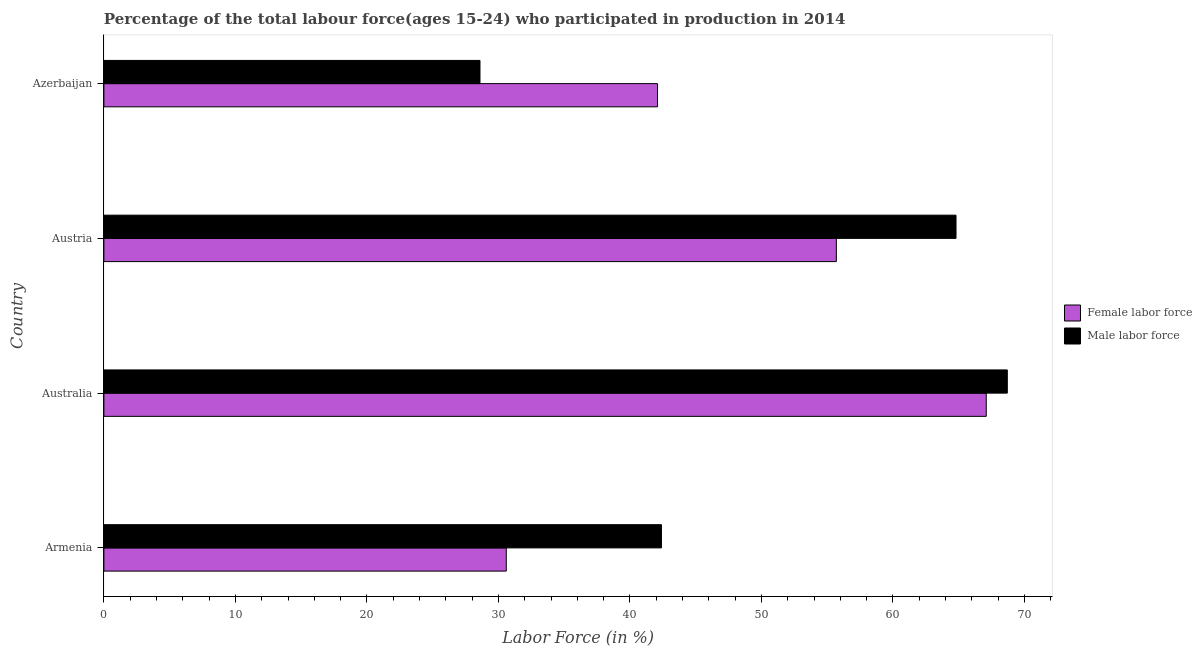How many different coloured bars are there?
Provide a succinct answer. 2. Are the number of bars per tick equal to the number of legend labels?
Ensure brevity in your answer.  Yes. Are the number of bars on each tick of the Y-axis equal?
Provide a short and direct response. Yes. What is the label of the 1st group of bars from the top?
Make the answer very short. Azerbaijan. In how many cases, is the number of bars for a given country not equal to the number of legend labels?
Offer a very short reply. 0. What is the percentage of female labor force in Armenia?
Offer a terse response. 30.6. Across all countries, what is the maximum percentage of female labor force?
Offer a terse response. 67.1. Across all countries, what is the minimum percentage of male labour force?
Keep it short and to the point. 28.6. In which country was the percentage of male labour force minimum?
Give a very brief answer. Azerbaijan. What is the total percentage of male labour force in the graph?
Provide a succinct answer. 204.5. What is the difference between the percentage of female labor force in Australia and that in Austria?
Your response must be concise. 11.4. What is the difference between the percentage of male labour force in Austria and the percentage of female labor force in Armenia?
Ensure brevity in your answer.  34.2. What is the average percentage of female labor force per country?
Your answer should be compact. 48.88. What is the difference between the percentage of male labour force and percentage of female labor force in Armenia?
Your answer should be very brief. 11.8. In how many countries, is the percentage of male labour force greater than 24 %?
Give a very brief answer. 4. What is the ratio of the percentage of male labour force in Armenia to that in Australia?
Your response must be concise. 0.62. Is the percentage of female labor force in Australia less than that in Austria?
Make the answer very short. No. Is the difference between the percentage of male labour force in Australia and Azerbaijan greater than the difference between the percentage of female labor force in Australia and Azerbaijan?
Offer a very short reply. Yes. What is the difference between the highest and the second highest percentage of female labor force?
Your response must be concise. 11.4. What is the difference between the highest and the lowest percentage of male labour force?
Give a very brief answer. 40.1. Is the sum of the percentage of female labor force in Australia and Azerbaijan greater than the maximum percentage of male labour force across all countries?
Keep it short and to the point. Yes. What does the 1st bar from the top in Azerbaijan represents?
Ensure brevity in your answer.  Male labor force. What does the 2nd bar from the bottom in Austria represents?
Your answer should be compact. Male labor force. What is the difference between two consecutive major ticks on the X-axis?
Offer a terse response. 10. What is the title of the graph?
Offer a terse response. Percentage of the total labour force(ages 15-24) who participated in production in 2014. What is the label or title of the X-axis?
Ensure brevity in your answer.  Labor Force (in %). What is the Labor Force (in %) of Female labor force in Armenia?
Your response must be concise. 30.6. What is the Labor Force (in %) of Male labor force in Armenia?
Provide a short and direct response. 42.4. What is the Labor Force (in %) of Female labor force in Australia?
Provide a short and direct response. 67.1. What is the Labor Force (in %) in Male labor force in Australia?
Give a very brief answer. 68.7. What is the Labor Force (in %) in Female labor force in Austria?
Offer a terse response. 55.7. What is the Labor Force (in %) of Male labor force in Austria?
Provide a succinct answer. 64.8. What is the Labor Force (in %) of Female labor force in Azerbaijan?
Offer a terse response. 42.1. What is the Labor Force (in %) of Male labor force in Azerbaijan?
Make the answer very short. 28.6. Across all countries, what is the maximum Labor Force (in %) in Female labor force?
Offer a very short reply. 67.1. Across all countries, what is the maximum Labor Force (in %) of Male labor force?
Your response must be concise. 68.7. Across all countries, what is the minimum Labor Force (in %) in Female labor force?
Provide a short and direct response. 30.6. Across all countries, what is the minimum Labor Force (in %) in Male labor force?
Your answer should be compact. 28.6. What is the total Labor Force (in %) in Female labor force in the graph?
Give a very brief answer. 195.5. What is the total Labor Force (in %) of Male labor force in the graph?
Your answer should be very brief. 204.5. What is the difference between the Labor Force (in %) in Female labor force in Armenia and that in Australia?
Ensure brevity in your answer.  -36.5. What is the difference between the Labor Force (in %) of Male labor force in Armenia and that in Australia?
Make the answer very short. -26.3. What is the difference between the Labor Force (in %) of Female labor force in Armenia and that in Austria?
Keep it short and to the point. -25.1. What is the difference between the Labor Force (in %) of Male labor force in Armenia and that in Austria?
Your answer should be very brief. -22.4. What is the difference between the Labor Force (in %) of Male labor force in Armenia and that in Azerbaijan?
Provide a short and direct response. 13.8. What is the difference between the Labor Force (in %) of Female labor force in Australia and that in Austria?
Your response must be concise. 11.4. What is the difference between the Labor Force (in %) in Male labor force in Australia and that in Austria?
Offer a terse response. 3.9. What is the difference between the Labor Force (in %) in Male labor force in Australia and that in Azerbaijan?
Keep it short and to the point. 40.1. What is the difference between the Labor Force (in %) of Female labor force in Austria and that in Azerbaijan?
Make the answer very short. 13.6. What is the difference between the Labor Force (in %) of Male labor force in Austria and that in Azerbaijan?
Your answer should be very brief. 36.2. What is the difference between the Labor Force (in %) in Female labor force in Armenia and the Labor Force (in %) in Male labor force in Australia?
Offer a very short reply. -38.1. What is the difference between the Labor Force (in %) of Female labor force in Armenia and the Labor Force (in %) of Male labor force in Austria?
Give a very brief answer. -34.2. What is the difference between the Labor Force (in %) of Female labor force in Armenia and the Labor Force (in %) of Male labor force in Azerbaijan?
Your answer should be very brief. 2. What is the difference between the Labor Force (in %) of Female labor force in Australia and the Labor Force (in %) of Male labor force in Austria?
Provide a short and direct response. 2.3. What is the difference between the Labor Force (in %) in Female labor force in Australia and the Labor Force (in %) in Male labor force in Azerbaijan?
Offer a terse response. 38.5. What is the difference between the Labor Force (in %) in Female labor force in Austria and the Labor Force (in %) in Male labor force in Azerbaijan?
Keep it short and to the point. 27.1. What is the average Labor Force (in %) of Female labor force per country?
Ensure brevity in your answer.  48.88. What is the average Labor Force (in %) of Male labor force per country?
Keep it short and to the point. 51.12. What is the difference between the Labor Force (in %) in Female labor force and Labor Force (in %) in Male labor force in Australia?
Provide a succinct answer. -1.6. What is the ratio of the Labor Force (in %) of Female labor force in Armenia to that in Australia?
Your answer should be compact. 0.46. What is the ratio of the Labor Force (in %) of Male labor force in Armenia to that in Australia?
Offer a very short reply. 0.62. What is the ratio of the Labor Force (in %) of Female labor force in Armenia to that in Austria?
Give a very brief answer. 0.55. What is the ratio of the Labor Force (in %) of Male labor force in Armenia to that in Austria?
Ensure brevity in your answer.  0.65. What is the ratio of the Labor Force (in %) in Female labor force in Armenia to that in Azerbaijan?
Your response must be concise. 0.73. What is the ratio of the Labor Force (in %) in Male labor force in Armenia to that in Azerbaijan?
Keep it short and to the point. 1.48. What is the ratio of the Labor Force (in %) of Female labor force in Australia to that in Austria?
Provide a short and direct response. 1.2. What is the ratio of the Labor Force (in %) in Male labor force in Australia to that in Austria?
Make the answer very short. 1.06. What is the ratio of the Labor Force (in %) in Female labor force in Australia to that in Azerbaijan?
Provide a short and direct response. 1.59. What is the ratio of the Labor Force (in %) of Male labor force in Australia to that in Azerbaijan?
Make the answer very short. 2.4. What is the ratio of the Labor Force (in %) in Female labor force in Austria to that in Azerbaijan?
Ensure brevity in your answer.  1.32. What is the ratio of the Labor Force (in %) in Male labor force in Austria to that in Azerbaijan?
Offer a very short reply. 2.27. What is the difference between the highest and the second highest Labor Force (in %) of Male labor force?
Provide a short and direct response. 3.9. What is the difference between the highest and the lowest Labor Force (in %) in Female labor force?
Provide a short and direct response. 36.5. What is the difference between the highest and the lowest Labor Force (in %) in Male labor force?
Offer a terse response. 40.1. 